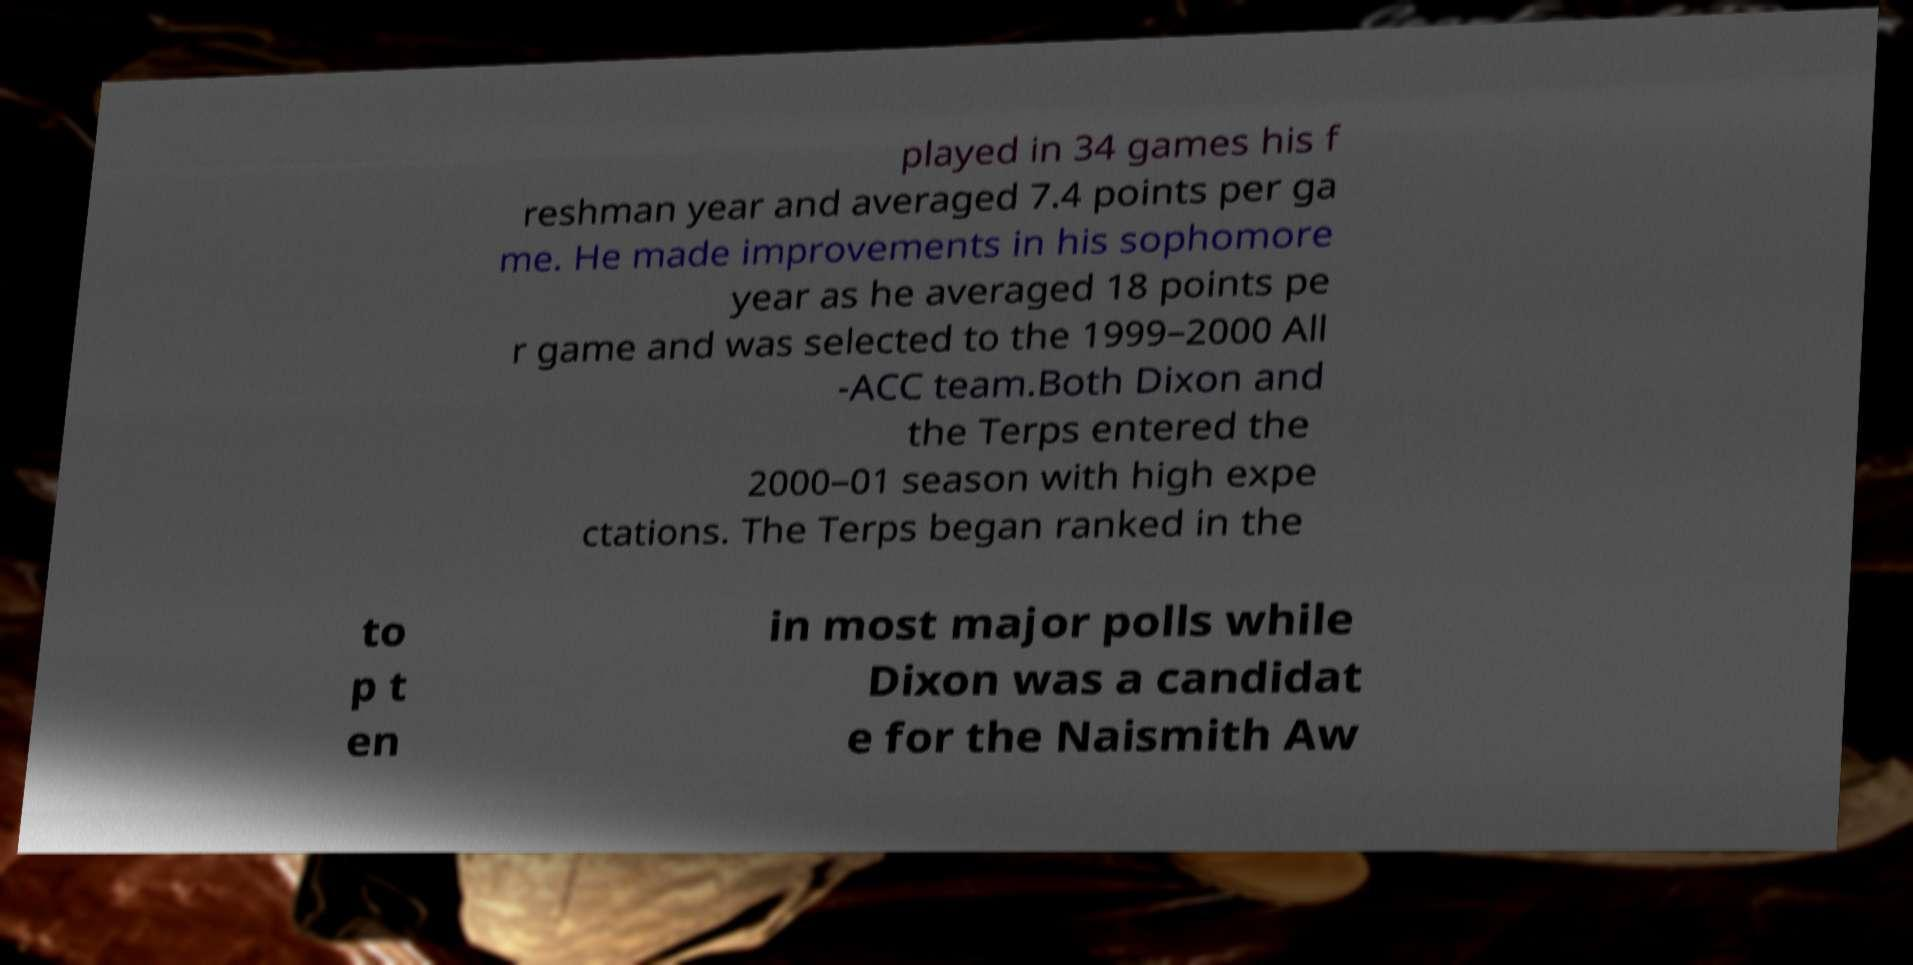Please read and relay the text visible in this image. What does it say? played in 34 games his f reshman year and averaged 7.4 points per ga me. He made improvements in his sophomore year as he averaged 18 points pe r game and was selected to the 1999–2000 All -ACC team.Both Dixon and the Terps entered the 2000–01 season with high expe ctations. The Terps began ranked in the to p t en in most major polls while Dixon was a candidat e for the Naismith Aw 